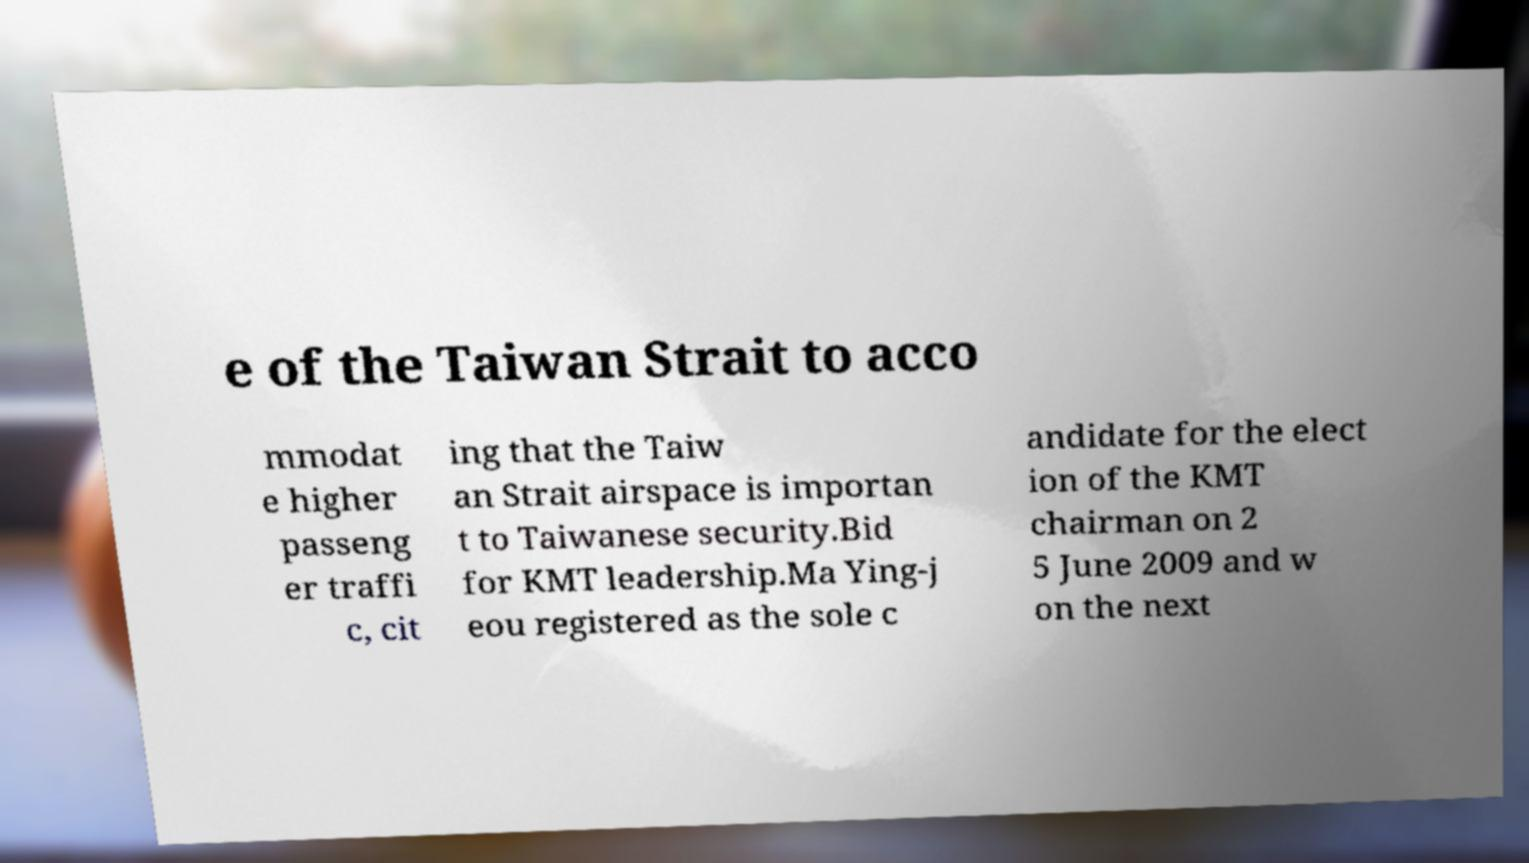Could you assist in decoding the text presented in this image and type it out clearly? e of the Taiwan Strait to acco mmodat e higher passeng er traffi c, cit ing that the Taiw an Strait airspace is importan t to Taiwanese security.Bid for KMT leadership.Ma Ying-j eou registered as the sole c andidate for the elect ion of the KMT chairman on 2 5 June 2009 and w on the next 